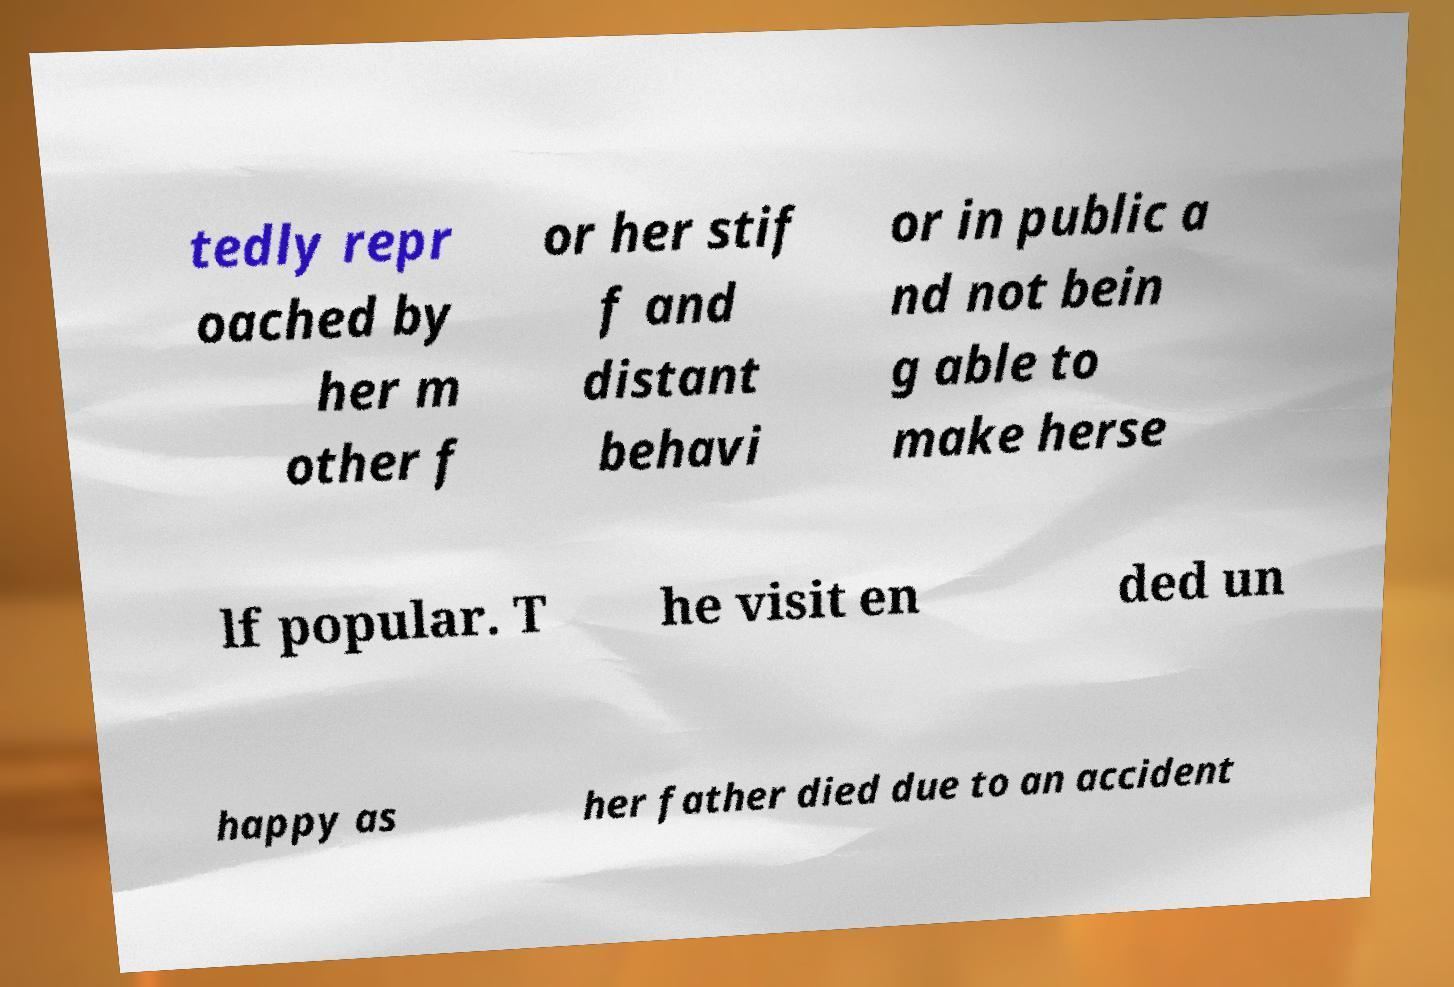There's text embedded in this image that I need extracted. Can you transcribe it verbatim? tedly repr oached by her m other f or her stif f and distant behavi or in public a nd not bein g able to make herse lf popular. T he visit en ded un happy as her father died due to an accident 